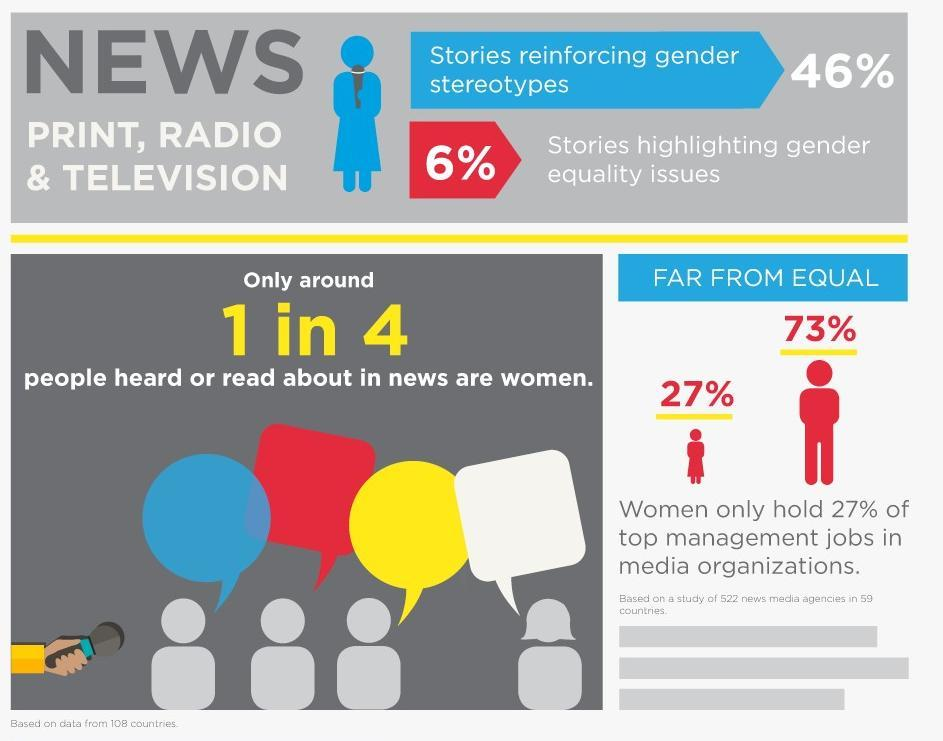What percent of news stories do not reinforce gender stereotypes?
Answer the question with a short phrase. 54% Who holds the most top management jobs in media organizations- men or women? men 